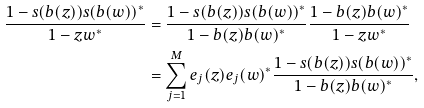<formula> <loc_0><loc_0><loc_500><loc_500>\frac { 1 - s ( b ( z ) ) s ( b ( w ) ) ^ { * } } { 1 - z w ^ { * } } & = \frac { 1 - s ( b ( z ) ) s ( b ( w ) ) ^ { * } } { 1 - b ( z ) b ( w ) ^ { * } } \frac { 1 - b ( z ) b ( w ) ^ { * } } { 1 - z w ^ { * } } \\ & = \sum _ { j = 1 } ^ { M } e _ { j } ( z ) e _ { j } ( w ) ^ { * } \frac { 1 - s ( b ( z ) ) s ( b ( w ) ) ^ { * } } { 1 - b ( z ) b ( w ) ^ { * } } ,</formula> 